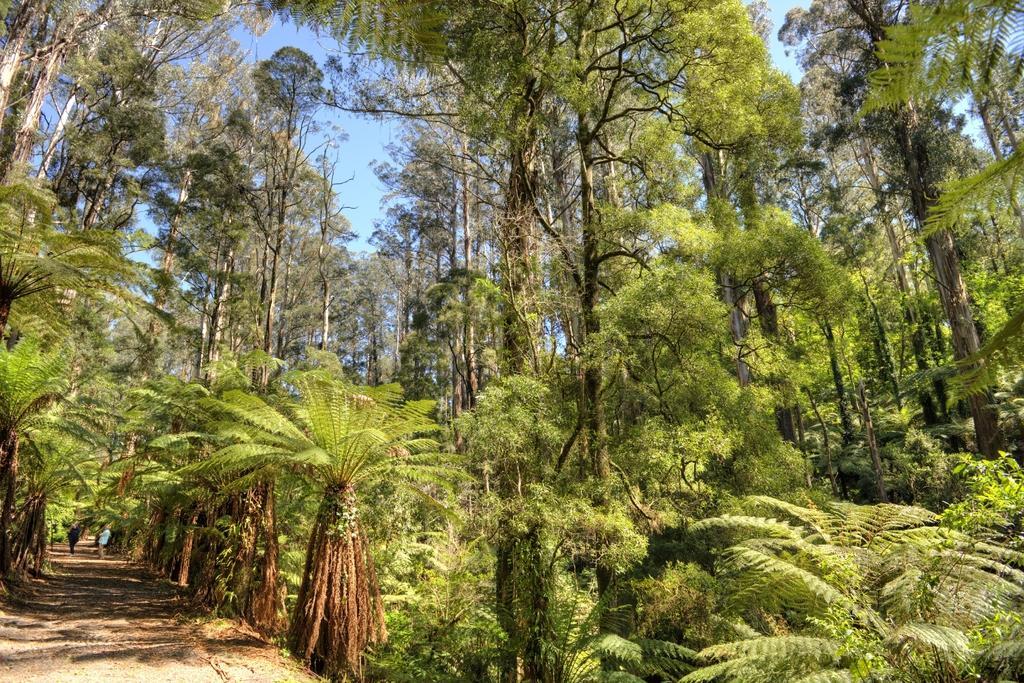In one or two sentences, can you explain what this image depicts? Here we can see trees. Background we can see people and sky. 